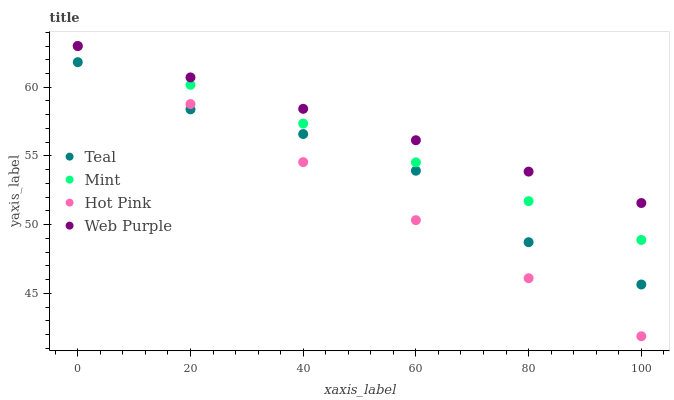Does Hot Pink have the minimum area under the curve?
Answer yes or no. Yes. Does Web Purple have the maximum area under the curve?
Answer yes or no. Yes. Does Mint have the minimum area under the curve?
Answer yes or no. No. Does Mint have the maximum area under the curve?
Answer yes or no. No. Is Web Purple the smoothest?
Answer yes or no. Yes. Is Teal the roughest?
Answer yes or no. Yes. Is Hot Pink the smoothest?
Answer yes or no. No. Is Hot Pink the roughest?
Answer yes or no. No. Does Hot Pink have the lowest value?
Answer yes or no. Yes. Does Mint have the lowest value?
Answer yes or no. No. Does Mint have the highest value?
Answer yes or no. Yes. Does Teal have the highest value?
Answer yes or no. No. Is Teal less than Mint?
Answer yes or no. Yes. Is Mint greater than Teal?
Answer yes or no. Yes. Does Web Purple intersect Hot Pink?
Answer yes or no. Yes. Is Web Purple less than Hot Pink?
Answer yes or no. No. Is Web Purple greater than Hot Pink?
Answer yes or no. No. Does Teal intersect Mint?
Answer yes or no. No. 